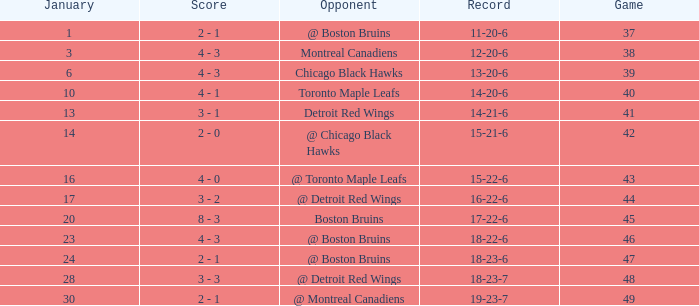What is the sum of all games that took place on january 20? 1.0. 